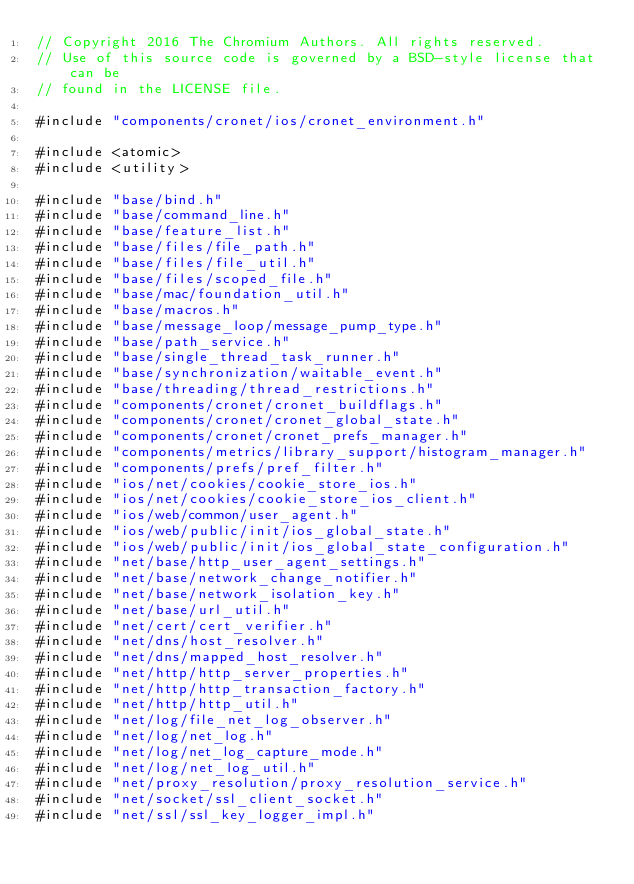<code> <loc_0><loc_0><loc_500><loc_500><_ObjectiveC_>// Copyright 2016 The Chromium Authors. All rights reserved.
// Use of this source code is governed by a BSD-style license that can be
// found in the LICENSE file.

#include "components/cronet/ios/cronet_environment.h"

#include <atomic>
#include <utility>

#include "base/bind.h"
#include "base/command_line.h"
#include "base/feature_list.h"
#include "base/files/file_path.h"
#include "base/files/file_util.h"
#include "base/files/scoped_file.h"
#include "base/mac/foundation_util.h"
#include "base/macros.h"
#include "base/message_loop/message_pump_type.h"
#include "base/path_service.h"
#include "base/single_thread_task_runner.h"
#include "base/synchronization/waitable_event.h"
#include "base/threading/thread_restrictions.h"
#include "components/cronet/cronet_buildflags.h"
#include "components/cronet/cronet_global_state.h"
#include "components/cronet/cronet_prefs_manager.h"
#include "components/metrics/library_support/histogram_manager.h"
#include "components/prefs/pref_filter.h"
#include "ios/net/cookies/cookie_store_ios.h"
#include "ios/net/cookies/cookie_store_ios_client.h"
#include "ios/web/common/user_agent.h"
#include "ios/web/public/init/ios_global_state.h"
#include "ios/web/public/init/ios_global_state_configuration.h"
#include "net/base/http_user_agent_settings.h"
#include "net/base/network_change_notifier.h"
#include "net/base/network_isolation_key.h"
#include "net/base/url_util.h"
#include "net/cert/cert_verifier.h"
#include "net/dns/host_resolver.h"
#include "net/dns/mapped_host_resolver.h"
#include "net/http/http_server_properties.h"
#include "net/http/http_transaction_factory.h"
#include "net/http/http_util.h"
#include "net/log/file_net_log_observer.h"
#include "net/log/net_log.h"
#include "net/log/net_log_capture_mode.h"
#include "net/log/net_log_util.h"
#include "net/proxy_resolution/proxy_resolution_service.h"
#include "net/socket/ssl_client_socket.h"
#include "net/ssl/ssl_key_logger_impl.h"</code> 